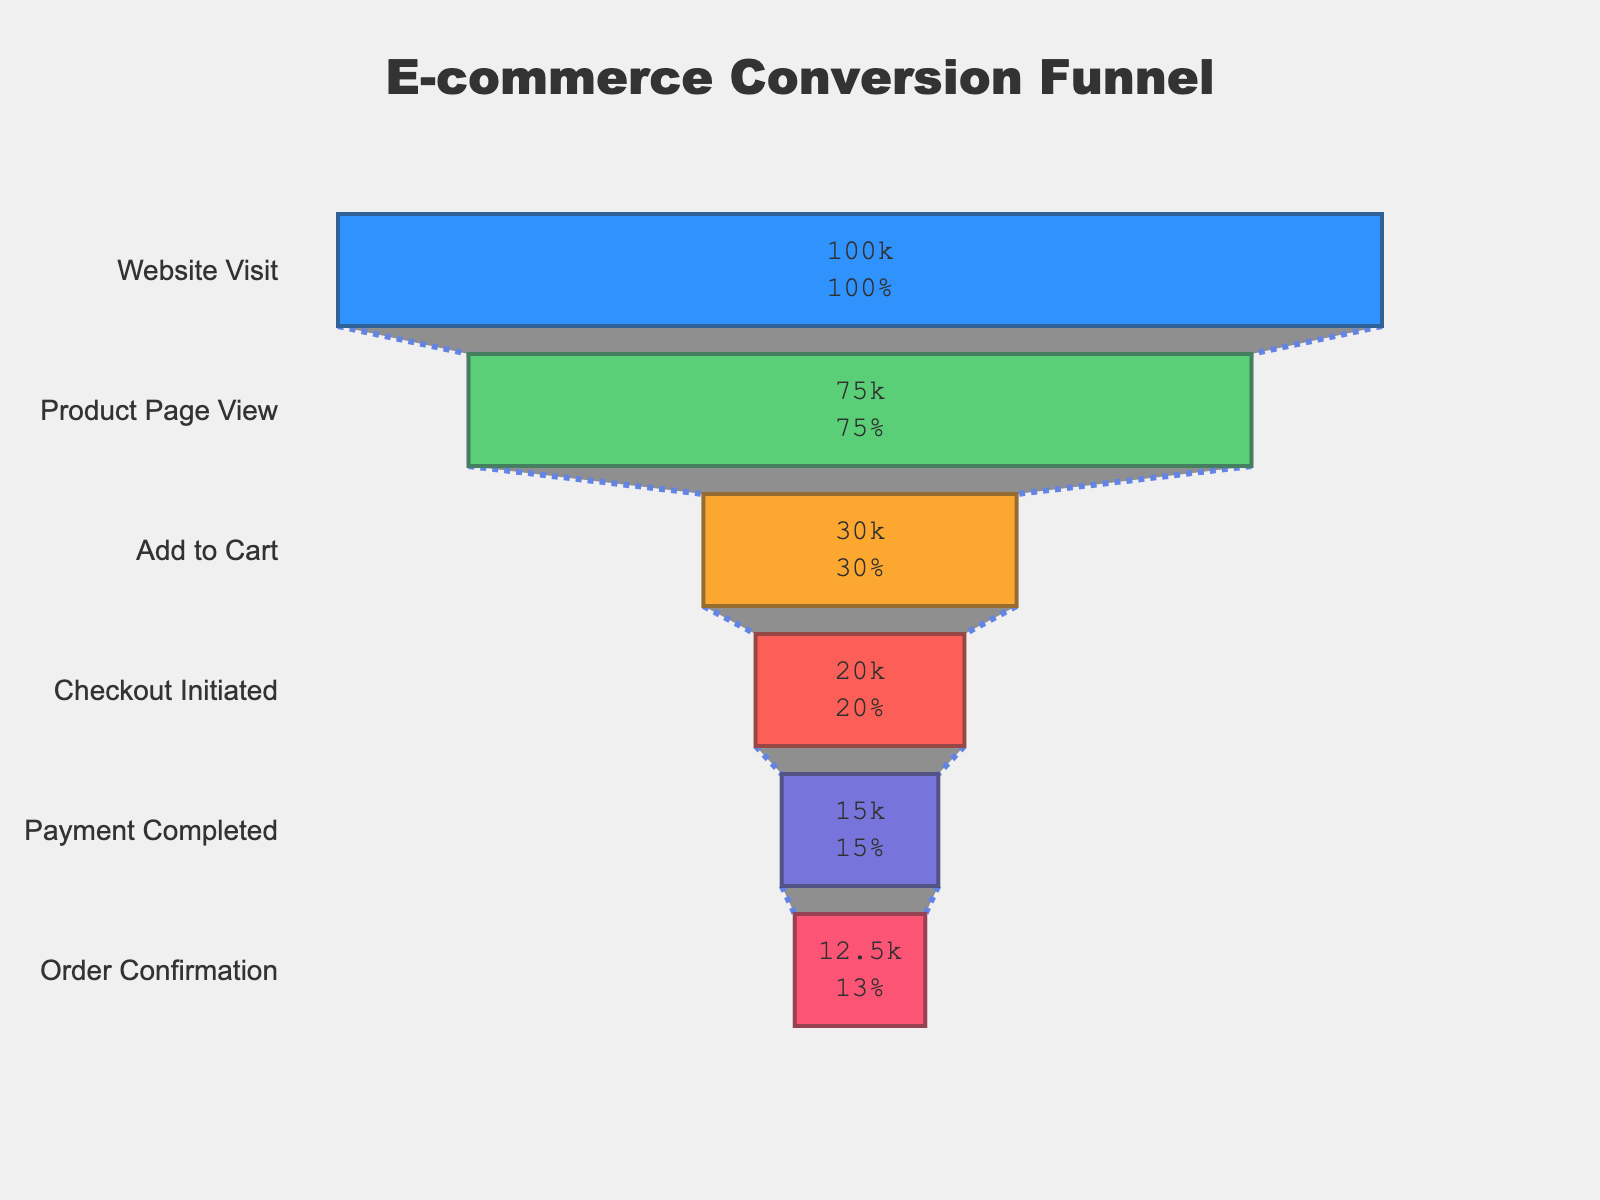What is the title of the funnel chart? The title of the chart is given at the top of the figure. It provides the main context for what the chart is about.
Answer: E-commerce Conversion Funnel How many users visited the website? The first stage of the funnel chart is "Website Visit" which shows the number of users.
Answer: 100,000 What is the percentage of users who added a product to the cart? The stage "Add to Cart" provides the number of users, and the percentage is also displayed inside the funnel.
Answer: 30% How many steps are there in the funnel chart? By counting the labeled steps on the y-axis of the funnel chart, we can determine the number of steps.
Answer: 6 How many users completed the payment but did not reach the order confirmation stage? Subtract the number of users at the "Order Confirmation" stage from the number of users at the "Payment Completed" stage. 15000 - 12500 = 2500
Answer: 2500 What fraction of website visitors completed the payment? The fraction can be calculated by dividing the number of users who completed the payment by the number of website visitors. 15000 / 100000 = 0.15
Answer: 0.15 Which stage in the funnel has the largest drop-off in users? By observing the difference in the number of users between consecutive stages, the largest drop-off occurs between "Product Page View" (75000) and "Add to Cart" (30000). The difference is 75000 - 30000 = 45000
Answer: Product Page View to Add to Cart Is the percentage drop from "Checkout Initiated" to "Payment Completed" greater than from "Add to Cart" to "Checkout Initiated"? The drop from "Checkout Initiated" (20000) to "Payment Completed" (15000) is 5000 users, which is 25%. The drop from "Add to Cart" (30000) to "Checkout Initiated" (20000) is 10000 users, which is 33.3%. 25% < 33.3%
Answer: No If 50 more users had completed the payment, what would be the new percentage for the "Payment Completed" stage relative to website visits? First, calculate the new number of users for "Payment Completed": 15000 + 50 = 15050. Then, divide this by the number of website visitors and multiply by 100 to get the percentage: (15050 / 100000) * 100 = 15.05%
Answer: 15.05% 